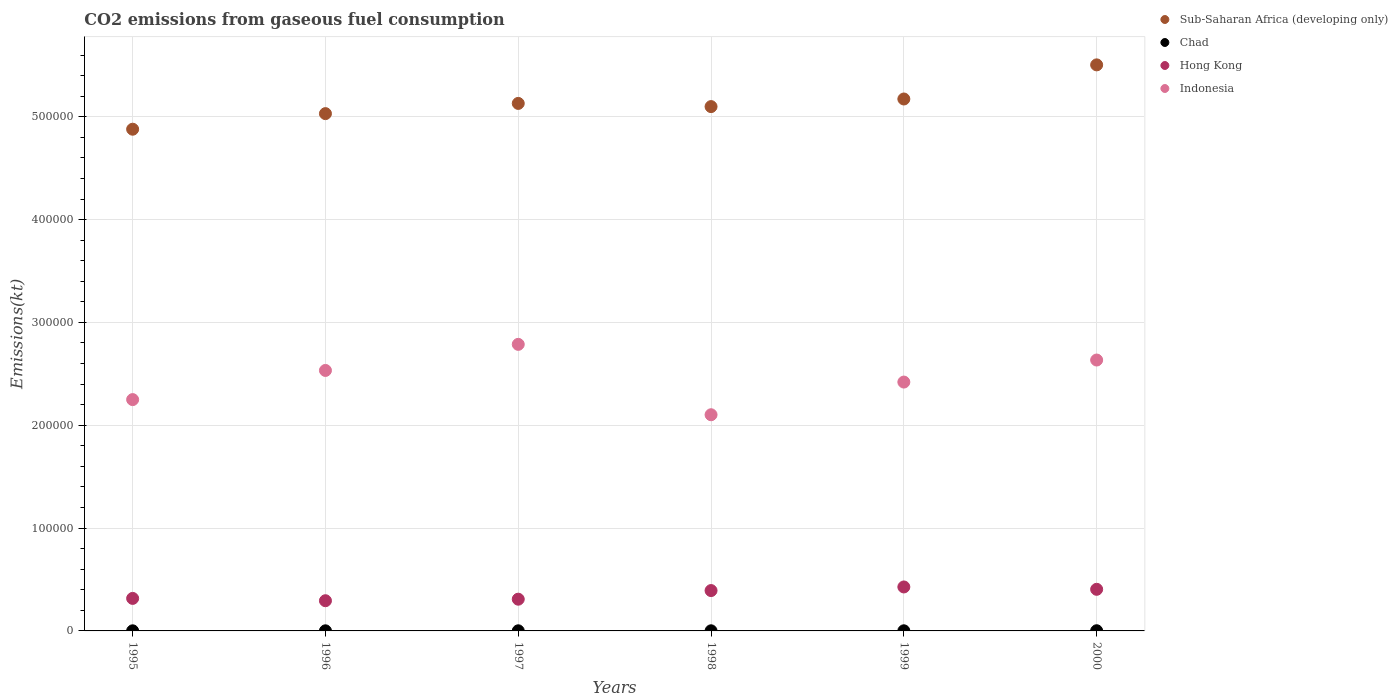How many different coloured dotlines are there?
Your answer should be compact. 4. Is the number of dotlines equal to the number of legend labels?
Ensure brevity in your answer.  Yes. What is the amount of CO2 emitted in Hong Kong in 1997?
Your response must be concise. 3.09e+04. Across all years, what is the maximum amount of CO2 emitted in Indonesia?
Make the answer very short. 2.79e+05. Across all years, what is the minimum amount of CO2 emitted in Indonesia?
Provide a succinct answer. 2.10e+05. In which year was the amount of CO2 emitted in Chad maximum?
Offer a very short reply. 2000. What is the total amount of CO2 emitted in Sub-Saharan Africa (developing only) in the graph?
Give a very brief answer. 3.08e+06. What is the difference between the amount of CO2 emitted in Hong Kong in 1997 and that in 2000?
Make the answer very short. -9611.21. What is the difference between the amount of CO2 emitted in Hong Kong in 1998 and the amount of CO2 emitted in Chad in 1995?
Provide a succinct answer. 3.91e+04. What is the average amount of CO2 emitted in Hong Kong per year?
Ensure brevity in your answer.  3.57e+04. In the year 1998, what is the difference between the amount of CO2 emitted in Hong Kong and amount of CO2 emitted in Chad?
Make the answer very short. 3.91e+04. What is the ratio of the amount of CO2 emitted in Sub-Saharan Africa (developing only) in 1997 to that in 1998?
Make the answer very short. 1.01. Is the amount of CO2 emitted in Hong Kong in 1995 less than that in 1996?
Ensure brevity in your answer.  No. What is the difference between the highest and the second highest amount of CO2 emitted in Chad?
Provide a succinct answer. 55. What is the difference between the highest and the lowest amount of CO2 emitted in Hong Kong?
Offer a terse response. 1.34e+04. In how many years, is the amount of CO2 emitted in Chad greater than the average amount of CO2 emitted in Chad taken over all years?
Ensure brevity in your answer.  1. Is the sum of the amount of CO2 emitted in Sub-Saharan Africa (developing only) in 1997 and 1998 greater than the maximum amount of CO2 emitted in Chad across all years?
Offer a very short reply. Yes. Is it the case that in every year, the sum of the amount of CO2 emitted in Sub-Saharan Africa (developing only) and amount of CO2 emitted in Chad  is greater than the amount of CO2 emitted in Indonesia?
Provide a succinct answer. Yes. Does the amount of CO2 emitted in Chad monotonically increase over the years?
Offer a terse response. No. How many dotlines are there?
Your response must be concise. 4. How many years are there in the graph?
Provide a succinct answer. 6. What is the difference between two consecutive major ticks on the Y-axis?
Give a very brief answer. 1.00e+05. Does the graph contain grids?
Ensure brevity in your answer.  Yes. Where does the legend appear in the graph?
Provide a short and direct response. Top right. How many legend labels are there?
Your answer should be compact. 4. How are the legend labels stacked?
Make the answer very short. Vertical. What is the title of the graph?
Keep it short and to the point. CO2 emissions from gaseous fuel consumption. Does "India" appear as one of the legend labels in the graph?
Give a very brief answer. No. What is the label or title of the Y-axis?
Your answer should be very brief. Emissions(kt). What is the Emissions(kt) of Sub-Saharan Africa (developing only) in 1995?
Keep it short and to the point. 4.88e+05. What is the Emissions(kt) of Chad in 1995?
Offer a terse response. 102.68. What is the Emissions(kt) in Hong Kong in 1995?
Give a very brief answer. 3.16e+04. What is the Emissions(kt) in Indonesia in 1995?
Provide a short and direct response. 2.25e+05. What is the Emissions(kt) in Sub-Saharan Africa (developing only) in 1996?
Your answer should be very brief. 5.03e+05. What is the Emissions(kt) in Chad in 1996?
Provide a succinct answer. 106.34. What is the Emissions(kt) of Hong Kong in 1996?
Your response must be concise. 2.94e+04. What is the Emissions(kt) of Indonesia in 1996?
Provide a succinct answer. 2.53e+05. What is the Emissions(kt) of Sub-Saharan Africa (developing only) in 1997?
Offer a terse response. 5.13e+05. What is the Emissions(kt) in Chad in 1997?
Give a very brief answer. 113.68. What is the Emissions(kt) in Hong Kong in 1997?
Your response must be concise. 3.09e+04. What is the Emissions(kt) of Indonesia in 1997?
Make the answer very short. 2.79e+05. What is the Emissions(kt) in Sub-Saharan Africa (developing only) in 1998?
Ensure brevity in your answer.  5.10e+05. What is the Emissions(kt) in Chad in 1998?
Your answer should be very brief. 113.68. What is the Emissions(kt) in Hong Kong in 1998?
Give a very brief answer. 3.92e+04. What is the Emissions(kt) of Indonesia in 1998?
Your response must be concise. 2.10e+05. What is the Emissions(kt) in Sub-Saharan Africa (developing only) in 1999?
Your answer should be compact. 5.17e+05. What is the Emissions(kt) of Chad in 1999?
Provide a succinct answer. 121.01. What is the Emissions(kt) of Hong Kong in 1999?
Offer a terse response. 4.28e+04. What is the Emissions(kt) of Indonesia in 1999?
Offer a terse response. 2.42e+05. What is the Emissions(kt) of Sub-Saharan Africa (developing only) in 2000?
Offer a very short reply. 5.50e+05. What is the Emissions(kt) in Chad in 2000?
Give a very brief answer. 176.02. What is the Emissions(kt) in Hong Kong in 2000?
Give a very brief answer. 4.05e+04. What is the Emissions(kt) in Indonesia in 2000?
Offer a very short reply. 2.63e+05. Across all years, what is the maximum Emissions(kt) in Sub-Saharan Africa (developing only)?
Make the answer very short. 5.50e+05. Across all years, what is the maximum Emissions(kt) of Chad?
Your answer should be compact. 176.02. Across all years, what is the maximum Emissions(kt) of Hong Kong?
Give a very brief answer. 4.28e+04. Across all years, what is the maximum Emissions(kt) in Indonesia?
Provide a short and direct response. 2.79e+05. Across all years, what is the minimum Emissions(kt) of Sub-Saharan Africa (developing only)?
Ensure brevity in your answer.  4.88e+05. Across all years, what is the minimum Emissions(kt) in Chad?
Your answer should be very brief. 102.68. Across all years, what is the minimum Emissions(kt) in Hong Kong?
Make the answer very short. 2.94e+04. Across all years, what is the minimum Emissions(kt) in Indonesia?
Ensure brevity in your answer.  2.10e+05. What is the total Emissions(kt) of Sub-Saharan Africa (developing only) in the graph?
Your response must be concise. 3.08e+06. What is the total Emissions(kt) of Chad in the graph?
Provide a short and direct response. 733.4. What is the total Emissions(kt) in Hong Kong in the graph?
Provide a succinct answer. 2.14e+05. What is the total Emissions(kt) of Indonesia in the graph?
Your response must be concise. 1.47e+06. What is the difference between the Emissions(kt) of Sub-Saharan Africa (developing only) in 1995 and that in 1996?
Your response must be concise. -1.52e+04. What is the difference between the Emissions(kt) in Chad in 1995 and that in 1996?
Provide a succinct answer. -3.67. What is the difference between the Emissions(kt) in Hong Kong in 1995 and that in 1996?
Offer a terse response. 2255.2. What is the difference between the Emissions(kt) in Indonesia in 1995 and that in 1996?
Keep it short and to the point. -2.83e+04. What is the difference between the Emissions(kt) in Sub-Saharan Africa (developing only) in 1995 and that in 1997?
Provide a succinct answer. -2.51e+04. What is the difference between the Emissions(kt) of Chad in 1995 and that in 1997?
Make the answer very short. -11. What is the difference between the Emissions(kt) of Hong Kong in 1995 and that in 1997?
Your answer should be compact. 766.4. What is the difference between the Emissions(kt) in Indonesia in 1995 and that in 1997?
Your answer should be very brief. -5.37e+04. What is the difference between the Emissions(kt) of Sub-Saharan Africa (developing only) in 1995 and that in 1998?
Offer a very short reply. -2.20e+04. What is the difference between the Emissions(kt) of Chad in 1995 and that in 1998?
Ensure brevity in your answer.  -11. What is the difference between the Emissions(kt) of Hong Kong in 1995 and that in 1998?
Your answer should be very brief. -7612.69. What is the difference between the Emissions(kt) of Indonesia in 1995 and that in 1998?
Offer a terse response. 1.47e+04. What is the difference between the Emissions(kt) in Sub-Saharan Africa (developing only) in 1995 and that in 1999?
Keep it short and to the point. -2.94e+04. What is the difference between the Emissions(kt) in Chad in 1995 and that in 1999?
Your answer should be compact. -18.34. What is the difference between the Emissions(kt) of Hong Kong in 1995 and that in 1999?
Make the answer very short. -1.11e+04. What is the difference between the Emissions(kt) in Indonesia in 1995 and that in 1999?
Keep it short and to the point. -1.70e+04. What is the difference between the Emissions(kt) in Sub-Saharan Africa (developing only) in 1995 and that in 2000?
Offer a very short reply. -6.26e+04. What is the difference between the Emissions(kt) of Chad in 1995 and that in 2000?
Your answer should be compact. -73.34. What is the difference between the Emissions(kt) in Hong Kong in 1995 and that in 2000?
Your response must be concise. -8844.8. What is the difference between the Emissions(kt) of Indonesia in 1995 and that in 2000?
Provide a succinct answer. -3.85e+04. What is the difference between the Emissions(kt) in Sub-Saharan Africa (developing only) in 1996 and that in 1997?
Keep it short and to the point. -9932.87. What is the difference between the Emissions(kt) of Chad in 1996 and that in 1997?
Ensure brevity in your answer.  -7.33. What is the difference between the Emissions(kt) in Hong Kong in 1996 and that in 1997?
Provide a succinct answer. -1488.8. What is the difference between the Emissions(kt) in Indonesia in 1996 and that in 1997?
Your answer should be compact. -2.54e+04. What is the difference between the Emissions(kt) of Sub-Saharan Africa (developing only) in 1996 and that in 1998?
Keep it short and to the point. -6831.61. What is the difference between the Emissions(kt) of Chad in 1996 and that in 1998?
Give a very brief answer. -7.33. What is the difference between the Emissions(kt) of Hong Kong in 1996 and that in 1998?
Ensure brevity in your answer.  -9867.9. What is the difference between the Emissions(kt) in Indonesia in 1996 and that in 1998?
Ensure brevity in your answer.  4.31e+04. What is the difference between the Emissions(kt) of Sub-Saharan Africa (developing only) in 1996 and that in 1999?
Keep it short and to the point. -1.42e+04. What is the difference between the Emissions(kt) of Chad in 1996 and that in 1999?
Offer a very short reply. -14.67. What is the difference between the Emissions(kt) in Hong Kong in 1996 and that in 1999?
Ensure brevity in your answer.  -1.34e+04. What is the difference between the Emissions(kt) of Indonesia in 1996 and that in 1999?
Your answer should be very brief. 1.13e+04. What is the difference between the Emissions(kt) in Sub-Saharan Africa (developing only) in 1996 and that in 2000?
Ensure brevity in your answer.  -4.74e+04. What is the difference between the Emissions(kt) of Chad in 1996 and that in 2000?
Your response must be concise. -69.67. What is the difference between the Emissions(kt) of Hong Kong in 1996 and that in 2000?
Make the answer very short. -1.11e+04. What is the difference between the Emissions(kt) in Indonesia in 1996 and that in 2000?
Ensure brevity in your answer.  -1.01e+04. What is the difference between the Emissions(kt) in Sub-Saharan Africa (developing only) in 1997 and that in 1998?
Ensure brevity in your answer.  3101.26. What is the difference between the Emissions(kt) in Hong Kong in 1997 and that in 1998?
Keep it short and to the point. -8379.09. What is the difference between the Emissions(kt) in Indonesia in 1997 and that in 1998?
Offer a terse response. 6.84e+04. What is the difference between the Emissions(kt) of Sub-Saharan Africa (developing only) in 1997 and that in 1999?
Offer a very short reply. -4296.89. What is the difference between the Emissions(kt) in Chad in 1997 and that in 1999?
Provide a short and direct response. -7.33. What is the difference between the Emissions(kt) of Hong Kong in 1997 and that in 1999?
Give a very brief answer. -1.19e+04. What is the difference between the Emissions(kt) of Indonesia in 1997 and that in 1999?
Keep it short and to the point. 3.67e+04. What is the difference between the Emissions(kt) of Sub-Saharan Africa (developing only) in 1997 and that in 2000?
Provide a succinct answer. -3.75e+04. What is the difference between the Emissions(kt) in Chad in 1997 and that in 2000?
Your answer should be very brief. -62.34. What is the difference between the Emissions(kt) of Hong Kong in 1997 and that in 2000?
Offer a very short reply. -9611.21. What is the difference between the Emissions(kt) of Indonesia in 1997 and that in 2000?
Provide a short and direct response. 1.52e+04. What is the difference between the Emissions(kt) in Sub-Saharan Africa (developing only) in 1998 and that in 1999?
Provide a succinct answer. -7398.15. What is the difference between the Emissions(kt) in Chad in 1998 and that in 1999?
Offer a terse response. -7.33. What is the difference between the Emissions(kt) in Hong Kong in 1998 and that in 1999?
Make the answer very short. -3520.32. What is the difference between the Emissions(kt) in Indonesia in 1998 and that in 1999?
Keep it short and to the point. -3.18e+04. What is the difference between the Emissions(kt) in Sub-Saharan Africa (developing only) in 1998 and that in 2000?
Make the answer very short. -4.06e+04. What is the difference between the Emissions(kt) in Chad in 1998 and that in 2000?
Your answer should be compact. -62.34. What is the difference between the Emissions(kt) in Hong Kong in 1998 and that in 2000?
Your answer should be very brief. -1232.11. What is the difference between the Emissions(kt) of Indonesia in 1998 and that in 2000?
Offer a terse response. -5.32e+04. What is the difference between the Emissions(kt) of Sub-Saharan Africa (developing only) in 1999 and that in 2000?
Ensure brevity in your answer.  -3.32e+04. What is the difference between the Emissions(kt) in Chad in 1999 and that in 2000?
Your answer should be very brief. -55.01. What is the difference between the Emissions(kt) of Hong Kong in 1999 and that in 2000?
Keep it short and to the point. 2288.21. What is the difference between the Emissions(kt) of Indonesia in 1999 and that in 2000?
Your answer should be compact. -2.14e+04. What is the difference between the Emissions(kt) in Sub-Saharan Africa (developing only) in 1995 and the Emissions(kt) in Chad in 1996?
Keep it short and to the point. 4.88e+05. What is the difference between the Emissions(kt) in Sub-Saharan Africa (developing only) in 1995 and the Emissions(kt) in Hong Kong in 1996?
Ensure brevity in your answer.  4.59e+05. What is the difference between the Emissions(kt) in Sub-Saharan Africa (developing only) in 1995 and the Emissions(kt) in Indonesia in 1996?
Provide a short and direct response. 2.35e+05. What is the difference between the Emissions(kt) in Chad in 1995 and the Emissions(kt) in Hong Kong in 1996?
Provide a succinct answer. -2.93e+04. What is the difference between the Emissions(kt) of Chad in 1995 and the Emissions(kt) of Indonesia in 1996?
Your response must be concise. -2.53e+05. What is the difference between the Emissions(kt) in Hong Kong in 1995 and the Emissions(kt) in Indonesia in 1996?
Make the answer very short. -2.22e+05. What is the difference between the Emissions(kt) of Sub-Saharan Africa (developing only) in 1995 and the Emissions(kt) of Chad in 1997?
Ensure brevity in your answer.  4.88e+05. What is the difference between the Emissions(kt) of Sub-Saharan Africa (developing only) in 1995 and the Emissions(kt) of Hong Kong in 1997?
Give a very brief answer. 4.57e+05. What is the difference between the Emissions(kt) in Sub-Saharan Africa (developing only) in 1995 and the Emissions(kt) in Indonesia in 1997?
Keep it short and to the point. 2.09e+05. What is the difference between the Emissions(kt) of Chad in 1995 and the Emissions(kt) of Hong Kong in 1997?
Your answer should be very brief. -3.08e+04. What is the difference between the Emissions(kt) of Chad in 1995 and the Emissions(kt) of Indonesia in 1997?
Provide a succinct answer. -2.79e+05. What is the difference between the Emissions(kt) in Hong Kong in 1995 and the Emissions(kt) in Indonesia in 1997?
Offer a very short reply. -2.47e+05. What is the difference between the Emissions(kt) of Sub-Saharan Africa (developing only) in 1995 and the Emissions(kt) of Chad in 1998?
Your answer should be very brief. 4.88e+05. What is the difference between the Emissions(kt) in Sub-Saharan Africa (developing only) in 1995 and the Emissions(kt) in Hong Kong in 1998?
Ensure brevity in your answer.  4.49e+05. What is the difference between the Emissions(kt) in Sub-Saharan Africa (developing only) in 1995 and the Emissions(kt) in Indonesia in 1998?
Keep it short and to the point. 2.78e+05. What is the difference between the Emissions(kt) of Chad in 1995 and the Emissions(kt) of Hong Kong in 1998?
Provide a short and direct response. -3.91e+04. What is the difference between the Emissions(kt) in Chad in 1995 and the Emissions(kt) in Indonesia in 1998?
Make the answer very short. -2.10e+05. What is the difference between the Emissions(kt) of Hong Kong in 1995 and the Emissions(kt) of Indonesia in 1998?
Your answer should be very brief. -1.79e+05. What is the difference between the Emissions(kt) in Sub-Saharan Africa (developing only) in 1995 and the Emissions(kt) in Chad in 1999?
Make the answer very short. 4.88e+05. What is the difference between the Emissions(kt) of Sub-Saharan Africa (developing only) in 1995 and the Emissions(kt) of Hong Kong in 1999?
Provide a short and direct response. 4.45e+05. What is the difference between the Emissions(kt) in Sub-Saharan Africa (developing only) in 1995 and the Emissions(kt) in Indonesia in 1999?
Your answer should be very brief. 2.46e+05. What is the difference between the Emissions(kt) of Chad in 1995 and the Emissions(kt) of Hong Kong in 1999?
Keep it short and to the point. -4.27e+04. What is the difference between the Emissions(kt) in Chad in 1995 and the Emissions(kt) in Indonesia in 1999?
Your response must be concise. -2.42e+05. What is the difference between the Emissions(kt) in Hong Kong in 1995 and the Emissions(kt) in Indonesia in 1999?
Your response must be concise. -2.10e+05. What is the difference between the Emissions(kt) of Sub-Saharan Africa (developing only) in 1995 and the Emissions(kt) of Chad in 2000?
Your answer should be very brief. 4.88e+05. What is the difference between the Emissions(kt) in Sub-Saharan Africa (developing only) in 1995 and the Emissions(kt) in Hong Kong in 2000?
Offer a very short reply. 4.47e+05. What is the difference between the Emissions(kt) in Sub-Saharan Africa (developing only) in 1995 and the Emissions(kt) in Indonesia in 2000?
Offer a terse response. 2.24e+05. What is the difference between the Emissions(kt) of Chad in 1995 and the Emissions(kt) of Hong Kong in 2000?
Make the answer very short. -4.04e+04. What is the difference between the Emissions(kt) in Chad in 1995 and the Emissions(kt) in Indonesia in 2000?
Provide a short and direct response. -2.63e+05. What is the difference between the Emissions(kt) of Hong Kong in 1995 and the Emissions(kt) of Indonesia in 2000?
Make the answer very short. -2.32e+05. What is the difference between the Emissions(kt) in Sub-Saharan Africa (developing only) in 1996 and the Emissions(kt) in Chad in 1997?
Offer a very short reply. 5.03e+05. What is the difference between the Emissions(kt) of Sub-Saharan Africa (developing only) in 1996 and the Emissions(kt) of Hong Kong in 1997?
Keep it short and to the point. 4.72e+05. What is the difference between the Emissions(kt) of Sub-Saharan Africa (developing only) in 1996 and the Emissions(kt) of Indonesia in 1997?
Make the answer very short. 2.24e+05. What is the difference between the Emissions(kt) in Chad in 1996 and the Emissions(kt) in Hong Kong in 1997?
Give a very brief answer. -3.07e+04. What is the difference between the Emissions(kt) in Chad in 1996 and the Emissions(kt) in Indonesia in 1997?
Ensure brevity in your answer.  -2.79e+05. What is the difference between the Emissions(kt) of Hong Kong in 1996 and the Emissions(kt) of Indonesia in 1997?
Offer a very short reply. -2.49e+05. What is the difference between the Emissions(kt) in Sub-Saharan Africa (developing only) in 1996 and the Emissions(kt) in Chad in 1998?
Offer a terse response. 5.03e+05. What is the difference between the Emissions(kt) of Sub-Saharan Africa (developing only) in 1996 and the Emissions(kt) of Hong Kong in 1998?
Keep it short and to the point. 4.64e+05. What is the difference between the Emissions(kt) of Sub-Saharan Africa (developing only) in 1996 and the Emissions(kt) of Indonesia in 1998?
Provide a succinct answer. 2.93e+05. What is the difference between the Emissions(kt) of Chad in 1996 and the Emissions(kt) of Hong Kong in 1998?
Your answer should be compact. -3.91e+04. What is the difference between the Emissions(kt) of Chad in 1996 and the Emissions(kt) of Indonesia in 1998?
Provide a succinct answer. -2.10e+05. What is the difference between the Emissions(kt) of Hong Kong in 1996 and the Emissions(kt) of Indonesia in 1998?
Provide a succinct answer. -1.81e+05. What is the difference between the Emissions(kt) in Sub-Saharan Africa (developing only) in 1996 and the Emissions(kt) in Chad in 1999?
Keep it short and to the point. 5.03e+05. What is the difference between the Emissions(kt) in Sub-Saharan Africa (developing only) in 1996 and the Emissions(kt) in Hong Kong in 1999?
Provide a short and direct response. 4.60e+05. What is the difference between the Emissions(kt) in Sub-Saharan Africa (developing only) in 1996 and the Emissions(kt) in Indonesia in 1999?
Provide a short and direct response. 2.61e+05. What is the difference between the Emissions(kt) in Chad in 1996 and the Emissions(kt) in Hong Kong in 1999?
Make the answer very short. -4.26e+04. What is the difference between the Emissions(kt) in Chad in 1996 and the Emissions(kt) in Indonesia in 1999?
Your answer should be very brief. -2.42e+05. What is the difference between the Emissions(kt) of Hong Kong in 1996 and the Emissions(kt) of Indonesia in 1999?
Give a very brief answer. -2.13e+05. What is the difference between the Emissions(kt) in Sub-Saharan Africa (developing only) in 1996 and the Emissions(kt) in Chad in 2000?
Keep it short and to the point. 5.03e+05. What is the difference between the Emissions(kt) of Sub-Saharan Africa (developing only) in 1996 and the Emissions(kt) of Hong Kong in 2000?
Your answer should be compact. 4.63e+05. What is the difference between the Emissions(kt) in Sub-Saharan Africa (developing only) in 1996 and the Emissions(kt) in Indonesia in 2000?
Your answer should be very brief. 2.40e+05. What is the difference between the Emissions(kt) in Chad in 1996 and the Emissions(kt) in Hong Kong in 2000?
Your response must be concise. -4.04e+04. What is the difference between the Emissions(kt) of Chad in 1996 and the Emissions(kt) of Indonesia in 2000?
Your answer should be compact. -2.63e+05. What is the difference between the Emissions(kt) of Hong Kong in 1996 and the Emissions(kt) of Indonesia in 2000?
Ensure brevity in your answer.  -2.34e+05. What is the difference between the Emissions(kt) of Sub-Saharan Africa (developing only) in 1997 and the Emissions(kt) of Chad in 1998?
Your answer should be compact. 5.13e+05. What is the difference between the Emissions(kt) of Sub-Saharan Africa (developing only) in 1997 and the Emissions(kt) of Hong Kong in 1998?
Make the answer very short. 4.74e+05. What is the difference between the Emissions(kt) of Sub-Saharan Africa (developing only) in 1997 and the Emissions(kt) of Indonesia in 1998?
Your answer should be compact. 3.03e+05. What is the difference between the Emissions(kt) in Chad in 1997 and the Emissions(kt) in Hong Kong in 1998?
Offer a terse response. -3.91e+04. What is the difference between the Emissions(kt) in Chad in 1997 and the Emissions(kt) in Indonesia in 1998?
Your response must be concise. -2.10e+05. What is the difference between the Emissions(kt) in Hong Kong in 1997 and the Emissions(kt) in Indonesia in 1998?
Offer a terse response. -1.79e+05. What is the difference between the Emissions(kt) in Sub-Saharan Africa (developing only) in 1997 and the Emissions(kt) in Chad in 1999?
Ensure brevity in your answer.  5.13e+05. What is the difference between the Emissions(kt) in Sub-Saharan Africa (developing only) in 1997 and the Emissions(kt) in Hong Kong in 1999?
Provide a succinct answer. 4.70e+05. What is the difference between the Emissions(kt) of Sub-Saharan Africa (developing only) in 1997 and the Emissions(kt) of Indonesia in 1999?
Your response must be concise. 2.71e+05. What is the difference between the Emissions(kt) of Chad in 1997 and the Emissions(kt) of Hong Kong in 1999?
Make the answer very short. -4.26e+04. What is the difference between the Emissions(kt) in Chad in 1997 and the Emissions(kt) in Indonesia in 1999?
Keep it short and to the point. -2.42e+05. What is the difference between the Emissions(kt) of Hong Kong in 1997 and the Emissions(kt) of Indonesia in 1999?
Your answer should be very brief. -2.11e+05. What is the difference between the Emissions(kt) in Sub-Saharan Africa (developing only) in 1997 and the Emissions(kt) in Chad in 2000?
Offer a terse response. 5.13e+05. What is the difference between the Emissions(kt) in Sub-Saharan Africa (developing only) in 1997 and the Emissions(kt) in Hong Kong in 2000?
Provide a short and direct response. 4.72e+05. What is the difference between the Emissions(kt) of Sub-Saharan Africa (developing only) in 1997 and the Emissions(kt) of Indonesia in 2000?
Your answer should be compact. 2.50e+05. What is the difference between the Emissions(kt) in Chad in 1997 and the Emissions(kt) in Hong Kong in 2000?
Provide a succinct answer. -4.04e+04. What is the difference between the Emissions(kt) in Chad in 1997 and the Emissions(kt) in Indonesia in 2000?
Provide a succinct answer. -2.63e+05. What is the difference between the Emissions(kt) of Hong Kong in 1997 and the Emissions(kt) of Indonesia in 2000?
Make the answer very short. -2.33e+05. What is the difference between the Emissions(kt) of Sub-Saharan Africa (developing only) in 1998 and the Emissions(kt) of Chad in 1999?
Offer a terse response. 5.10e+05. What is the difference between the Emissions(kt) of Sub-Saharan Africa (developing only) in 1998 and the Emissions(kt) of Hong Kong in 1999?
Your response must be concise. 4.67e+05. What is the difference between the Emissions(kt) in Sub-Saharan Africa (developing only) in 1998 and the Emissions(kt) in Indonesia in 1999?
Ensure brevity in your answer.  2.68e+05. What is the difference between the Emissions(kt) of Chad in 1998 and the Emissions(kt) of Hong Kong in 1999?
Keep it short and to the point. -4.26e+04. What is the difference between the Emissions(kt) of Chad in 1998 and the Emissions(kt) of Indonesia in 1999?
Offer a terse response. -2.42e+05. What is the difference between the Emissions(kt) of Hong Kong in 1998 and the Emissions(kt) of Indonesia in 1999?
Your answer should be very brief. -2.03e+05. What is the difference between the Emissions(kt) of Sub-Saharan Africa (developing only) in 1998 and the Emissions(kt) of Chad in 2000?
Offer a very short reply. 5.10e+05. What is the difference between the Emissions(kt) of Sub-Saharan Africa (developing only) in 1998 and the Emissions(kt) of Hong Kong in 2000?
Provide a succinct answer. 4.69e+05. What is the difference between the Emissions(kt) in Sub-Saharan Africa (developing only) in 1998 and the Emissions(kt) in Indonesia in 2000?
Ensure brevity in your answer.  2.46e+05. What is the difference between the Emissions(kt) in Chad in 1998 and the Emissions(kt) in Hong Kong in 2000?
Give a very brief answer. -4.04e+04. What is the difference between the Emissions(kt) of Chad in 1998 and the Emissions(kt) of Indonesia in 2000?
Give a very brief answer. -2.63e+05. What is the difference between the Emissions(kt) of Hong Kong in 1998 and the Emissions(kt) of Indonesia in 2000?
Ensure brevity in your answer.  -2.24e+05. What is the difference between the Emissions(kt) of Sub-Saharan Africa (developing only) in 1999 and the Emissions(kt) of Chad in 2000?
Make the answer very short. 5.17e+05. What is the difference between the Emissions(kt) of Sub-Saharan Africa (developing only) in 1999 and the Emissions(kt) of Hong Kong in 2000?
Your response must be concise. 4.77e+05. What is the difference between the Emissions(kt) in Sub-Saharan Africa (developing only) in 1999 and the Emissions(kt) in Indonesia in 2000?
Offer a terse response. 2.54e+05. What is the difference between the Emissions(kt) in Chad in 1999 and the Emissions(kt) in Hong Kong in 2000?
Provide a succinct answer. -4.03e+04. What is the difference between the Emissions(kt) of Chad in 1999 and the Emissions(kt) of Indonesia in 2000?
Make the answer very short. -2.63e+05. What is the difference between the Emissions(kt) in Hong Kong in 1999 and the Emissions(kt) in Indonesia in 2000?
Offer a terse response. -2.21e+05. What is the average Emissions(kt) in Sub-Saharan Africa (developing only) per year?
Your answer should be very brief. 5.14e+05. What is the average Emissions(kt) of Chad per year?
Ensure brevity in your answer.  122.23. What is the average Emissions(kt) in Hong Kong per year?
Provide a short and direct response. 3.57e+04. What is the average Emissions(kt) of Indonesia per year?
Keep it short and to the point. 2.45e+05. In the year 1995, what is the difference between the Emissions(kt) of Sub-Saharan Africa (developing only) and Emissions(kt) of Chad?
Ensure brevity in your answer.  4.88e+05. In the year 1995, what is the difference between the Emissions(kt) in Sub-Saharan Africa (developing only) and Emissions(kt) in Hong Kong?
Provide a succinct answer. 4.56e+05. In the year 1995, what is the difference between the Emissions(kt) in Sub-Saharan Africa (developing only) and Emissions(kt) in Indonesia?
Ensure brevity in your answer.  2.63e+05. In the year 1995, what is the difference between the Emissions(kt) in Chad and Emissions(kt) in Hong Kong?
Your response must be concise. -3.15e+04. In the year 1995, what is the difference between the Emissions(kt) of Chad and Emissions(kt) of Indonesia?
Offer a terse response. -2.25e+05. In the year 1995, what is the difference between the Emissions(kt) of Hong Kong and Emissions(kt) of Indonesia?
Provide a short and direct response. -1.93e+05. In the year 1996, what is the difference between the Emissions(kt) of Sub-Saharan Africa (developing only) and Emissions(kt) of Chad?
Offer a very short reply. 5.03e+05. In the year 1996, what is the difference between the Emissions(kt) of Sub-Saharan Africa (developing only) and Emissions(kt) of Hong Kong?
Make the answer very short. 4.74e+05. In the year 1996, what is the difference between the Emissions(kt) of Sub-Saharan Africa (developing only) and Emissions(kt) of Indonesia?
Provide a succinct answer. 2.50e+05. In the year 1996, what is the difference between the Emissions(kt) in Chad and Emissions(kt) in Hong Kong?
Keep it short and to the point. -2.93e+04. In the year 1996, what is the difference between the Emissions(kt) of Chad and Emissions(kt) of Indonesia?
Your response must be concise. -2.53e+05. In the year 1996, what is the difference between the Emissions(kt) of Hong Kong and Emissions(kt) of Indonesia?
Make the answer very short. -2.24e+05. In the year 1997, what is the difference between the Emissions(kt) of Sub-Saharan Africa (developing only) and Emissions(kt) of Chad?
Make the answer very short. 5.13e+05. In the year 1997, what is the difference between the Emissions(kt) of Sub-Saharan Africa (developing only) and Emissions(kt) of Hong Kong?
Your answer should be compact. 4.82e+05. In the year 1997, what is the difference between the Emissions(kt) in Sub-Saharan Africa (developing only) and Emissions(kt) in Indonesia?
Ensure brevity in your answer.  2.34e+05. In the year 1997, what is the difference between the Emissions(kt) of Chad and Emissions(kt) of Hong Kong?
Provide a succinct answer. -3.07e+04. In the year 1997, what is the difference between the Emissions(kt) of Chad and Emissions(kt) of Indonesia?
Ensure brevity in your answer.  -2.79e+05. In the year 1997, what is the difference between the Emissions(kt) of Hong Kong and Emissions(kt) of Indonesia?
Your answer should be very brief. -2.48e+05. In the year 1998, what is the difference between the Emissions(kt) of Sub-Saharan Africa (developing only) and Emissions(kt) of Chad?
Make the answer very short. 5.10e+05. In the year 1998, what is the difference between the Emissions(kt) of Sub-Saharan Africa (developing only) and Emissions(kt) of Hong Kong?
Your answer should be very brief. 4.71e+05. In the year 1998, what is the difference between the Emissions(kt) in Sub-Saharan Africa (developing only) and Emissions(kt) in Indonesia?
Keep it short and to the point. 3.00e+05. In the year 1998, what is the difference between the Emissions(kt) of Chad and Emissions(kt) of Hong Kong?
Ensure brevity in your answer.  -3.91e+04. In the year 1998, what is the difference between the Emissions(kt) of Chad and Emissions(kt) of Indonesia?
Give a very brief answer. -2.10e+05. In the year 1998, what is the difference between the Emissions(kt) of Hong Kong and Emissions(kt) of Indonesia?
Your answer should be compact. -1.71e+05. In the year 1999, what is the difference between the Emissions(kt) of Sub-Saharan Africa (developing only) and Emissions(kt) of Chad?
Ensure brevity in your answer.  5.17e+05. In the year 1999, what is the difference between the Emissions(kt) in Sub-Saharan Africa (developing only) and Emissions(kt) in Hong Kong?
Provide a succinct answer. 4.75e+05. In the year 1999, what is the difference between the Emissions(kt) of Sub-Saharan Africa (developing only) and Emissions(kt) of Indonesia?
Provide a succinct answer. 2.75e+05. In the year 1999, what is the difference between the Emissions(kt) in Chad and Emissions(kt) in Hong Kong?
Your answer should be very brief. -4.26e+04. In the year 1999, what is the difference between the Emissions(kt) in Chad and Emissions(kt) in Indonesia?
Ensure brevity in your answer.  -2.42e+05. In the year 1999, what is the difference between the Emissions(kt) in Hong Kong and Emissions(kt) in Indonesia?
Give a very brief answer. -1.99e+05. In the year 2000, what is the difference between the Emissions(kt) of Sub-Saharan Africa (developing only) and Emissions(kt) of Chad?
Your answer should be very brief. 5.50e+05. In the year 2000, what is the difference between the Emissions(kt) in Sub-Saharan Africa (developing only) and Emissions(kt) in Hong Kong?
Keep it short and to the point. 5.10e+05. In the year 2000, what is the difference between the Emissions(kt) in Sub-Saharan Africa (developing only) and Emissions(kt) in Indonesia?
Offer a very short reply. 2.87e+05. In the year 2000, what is the difference between the Emissions(kt) in Chad and Emissions(kt) in Hong Kong?
Give a very brief answer. -4.03e+04. In the year 2000, what is the difference between the Emissions(kt) in Chad and Emissions(kt) in Indonesia?
Your answer should be very brief. -2.63e+05. In the year 2000, what is the difference between the Emissions(kt) in Hong Kong and Emissions(kt) in Indonesia?
Keep it short and to the point. -2.23e+05. What is the ratio of the Emissions(kt) of Sub-Saharan Africa (developing only) in 1995 to that in 1996?
Give a very brief answer. 0.97. What is the ratio of the Emissions(kt) in Chad in 1995 to that in 1996?
Give a very brief answer. 0.97. What is the ratio of the Emissions(kt) in Hong Kong in 1995 to that in 1996?
Provide a short and direct response. 1.08. What is the ratio of the Emissions(kt) in Indonesia in 1995 to that in 1996?
Keep it short and to the point. 0.89. What is the ratio of the Emissions(kt) of Sub-Saharan Africa (developing only) in 1995 to that in 1997?
Ensure brevity in your answer.  0.95. What is the ratio of the Emissions(kt) in Chad in 1995 to that in 1997?
Keep it short and to the point. 0.9. What is the ratio of the Emissions(kt) of Hong Kong in 1995 to that in 1997?
Provide a short and direct response. 1.02. What is the ratio of the Emissions(kt) of Indonesia in 1995 to that in 1997?
Make the answer very short. 0.81. What is the ratio of the Emissions(kt) in Sub-Saharan Africa (developing only) in 1995 to that in 1998?
Your response must be concise. 0.96. What is the ratio of the Emissions(kt) of Chad in 1995 to that in 1998?
Provide a short and direct response. 0.9. What is the ratio of the Emissions(kt) of Hong Kong in 1995 to that in 1998?
Make the answer very short. 0.81. What is the ratio of the Emissions(kt) of Indonesia in 1995 to that in 1998?
Offer a very short reply. 1.07. What is the ratio of the Emissions(kt) in Sub-Saharan Africa (developing only) in 1995 to that in 1999?
Offer a very short reply. 0.94. What is the ratio of the Emissions(kt) of Chad in 1995 to that in 1999?
Provide a succinct answer. 0.85. What is the ratio of the Emissions(kt) in Hong Kong in 1995 to that in 1999?
Offer a terse response. 0.74. What is the ratio of the Emissions(kt) in Indonesia in 1995 to that in 1999?
Make the answer very short. 0.93. What is the ratio of the Emissions(kt) of Sub-Saharan Africa (developing only) in 1995 to that in 2000?
Ensure brevity in your answer.  0.89. What is the ratio of the Emissions(kt) in Chad in 1995 to that in 2000?
Keep it short and to the point. 0.58. What is the ratio of the Emissions(kt) in Hong Kong in 1995 to that in 2000?
Make the answer very short. 0.78. What is the ratio of the Emissions(kt) in Indonesia in 1995 to that in 2000?
Offer a terse response. 0.85. What is the ratio of the Emissions(kt) in Sub-Saharan Africa (developing only) in 1996 to that in 1997?
Your answer should be very brief. 0.98. What is the ratio of the Emissions(kt) of Chad in 1996 to that in 1997?
Your answer should be very brief. 0.94. What is the ratio of the Emissions(kt) in Hong Kong in 1996 to that in 1997?
Ensure brevity in your answer.  0.95. What is the ratio of the Emissions(kt) in Indonesia in 1996 to that in 1997?
Your response must be concise. 0.91. What is the ratio of the Emissions(kt) in Sub-Saharan Africa (developing only) in 1996 to that in 1998?
Offer a terse response. 0.99. What is the ratio of the Emissions(kt) of Chad in 1996 to that in 1998?
Your response must be concise. 0.94. What is the ratio of the Emissions(kt) in Hong Kong in 1996 to that in 1998?
Provide a short and direct response. 0.75. What is the ratio of the Emissions(kt) in Indonesia in 1996 to that in 1998?
Offer a terse response. 1.2. What is the ratio of the Emissions(kt) in Sub-Saharan Africa (developing only) in 1996 to that in 1999?
Your answer should be compact. 0.97. What is the ratio of the Emissions(kt) in Chad in 1996 to that in 1999?
Your answer should be compact. 0.88. What is the ratio of the Emissions(kt) of Hong Kong in 1996 to that in 1999?
Provide a short and direct response. 0.69. What is the ratio of the Emissions(kt) in Indonesia in 1996 to that in 1999?
Your answer should be compact. 1.05. What is the ratio of the Emissions(kt) in Sub-Saharan Africa (developing only) in 1996 to that in 2000?
Provide a short and direct response. 0.91. What is the ratio of the Emissions(kt) in Chad in 1996 to that in 2000?
Provide a short and direct response. 0.6. What is the ratio of the Emissions(kt) of Hong Kong in 1996 to that in 2000?
Your answer should be compact. 0.73. What is the ratio of the Emissions(kt) in Indonesia in 1996 to that in 2000?
Offer a terse response. 0.96. What is the ratio of the Emissions(kt) of Hong Kong in 1997 to that in 1998?
Your answer should be very brief. 0.79. What is the ratio of the Emissions(kt) in Indonesia in 1997 to that in 1998?
Your answer should be compact. 1.33. What is the ratio of the Emissions(kt) in Chad in 1997 to that in 1999?
Your answer should be compact. 0.94. What is the ratio of the Emissions(kt) of Hong Kong in 1997 to that in 1999?
Ensure brevity in your answer.  0.72. What is the ratio of the Emissions(kt) in Indonesia in 1997 to that in 1999?
Provide a short and direct response. 1.15. What is the ratio of the Emissions(kt) in Sub-Saharan Africa (developing only) in 1997 to that in 2000?
Provide a short and direct response. 0.93. What is the ratio of the Emissions(kt) in Chad in 1997 to that in 2000?
Make the answer very short. 0.65. What is the ratio of the Emissions(kt) of Hong Kong in 1997 to that in 2000?
Give a very brief answer. 0.76. What is the ratio of the Emissions(kt) of Indonesia in 1997 to that in 2000?
Your answer should be compact. 1.06. What is the ratio of the Emissions(kt) of Sub-Saharan Africa (developing only) in 1998 to that in 1999?
Your answer should be compact. 0.99. What is the ratio of the Emissions(kt) in Chad in 1998 to that in 1999?
Provide a short and direct response. 0.94. What is the ratio of the Emissions(kt) of Hong Kong in 1998 to that in 1999?
Make the answer very short. 0.92. What is the ratio of the Emissions(kt) in Indonesia in 1998 to that in 1999?
Offer a very short reply. 0.87. What is the ratio of the Emissions(kt) of Sub-Saharan Africa (developing only) in 1998 to that in 2000?
Provide a short and direct response. 0.93. What is the ratio of the Emissions(kt) of Chad in 1998 to that in 2000?
Your response must be concise. 0.65. What is the ratio of the Emissions(kt) in Hong Kong in 1998 to that in 2000?
Your answer should be very brief. 0.97. What is the ratio of the Emissions(kt) of Indonesia in 1998 to that in 2000?
Your response must be concise. 0.8. What is the ratio of the Emissions(kt) of Sub-Saharan Africa (developing only) in 1999 to that in 2000?
Provide a succinct answer. 0.94. What is the ratio of the Emissions(kt) in Chad in 1999 to that in 2000?
Make the answer very short. 0.69. What is the ratio of the Emissions(kt) of Hong Kong in 1999 to that in 2000?
Provide a succinct answer. 1.06. What is the ratio of the Emissions(kt) of Indonesia in 1999 to that in 2000?
Offer a terse response. 0.92. What is the difference between the highest and the second highest Emissions(kt) in Sub-Saharan Africa (developing only)?
Provide a short and direct response. 3.32e+04. What is the difference between the highest and the second highest Emissions(kt) of Chad?
Provide a succinct answer. 55.01. What is the difference between the highest and the second highest Emissions(kt) of Hong Kong?
Give a very brief answer. 2288.21. What is the difference between the highest and the second highest Emissions(kt) in Indonesia?
Give a very brief answer. 1.52e+04. What is the difference between the highest and the lowest Emissions(kt) of Sub-Saharan Africa (developing only)?
Make the answer very short. 6.26e+04. What is the difference between the highest and the lowest Emissions(kt) of Chad?
Your answer should be very brief. 73.34. What is the difference between the highest and the lowest Emissions(kt) of Hong Kong?
Provide a succinct answer. 1.34e+04. What is the difference between the highest and the lowest Emissions(kt) in Indonesia?
Your answer should be compact. 6.84e+04. 